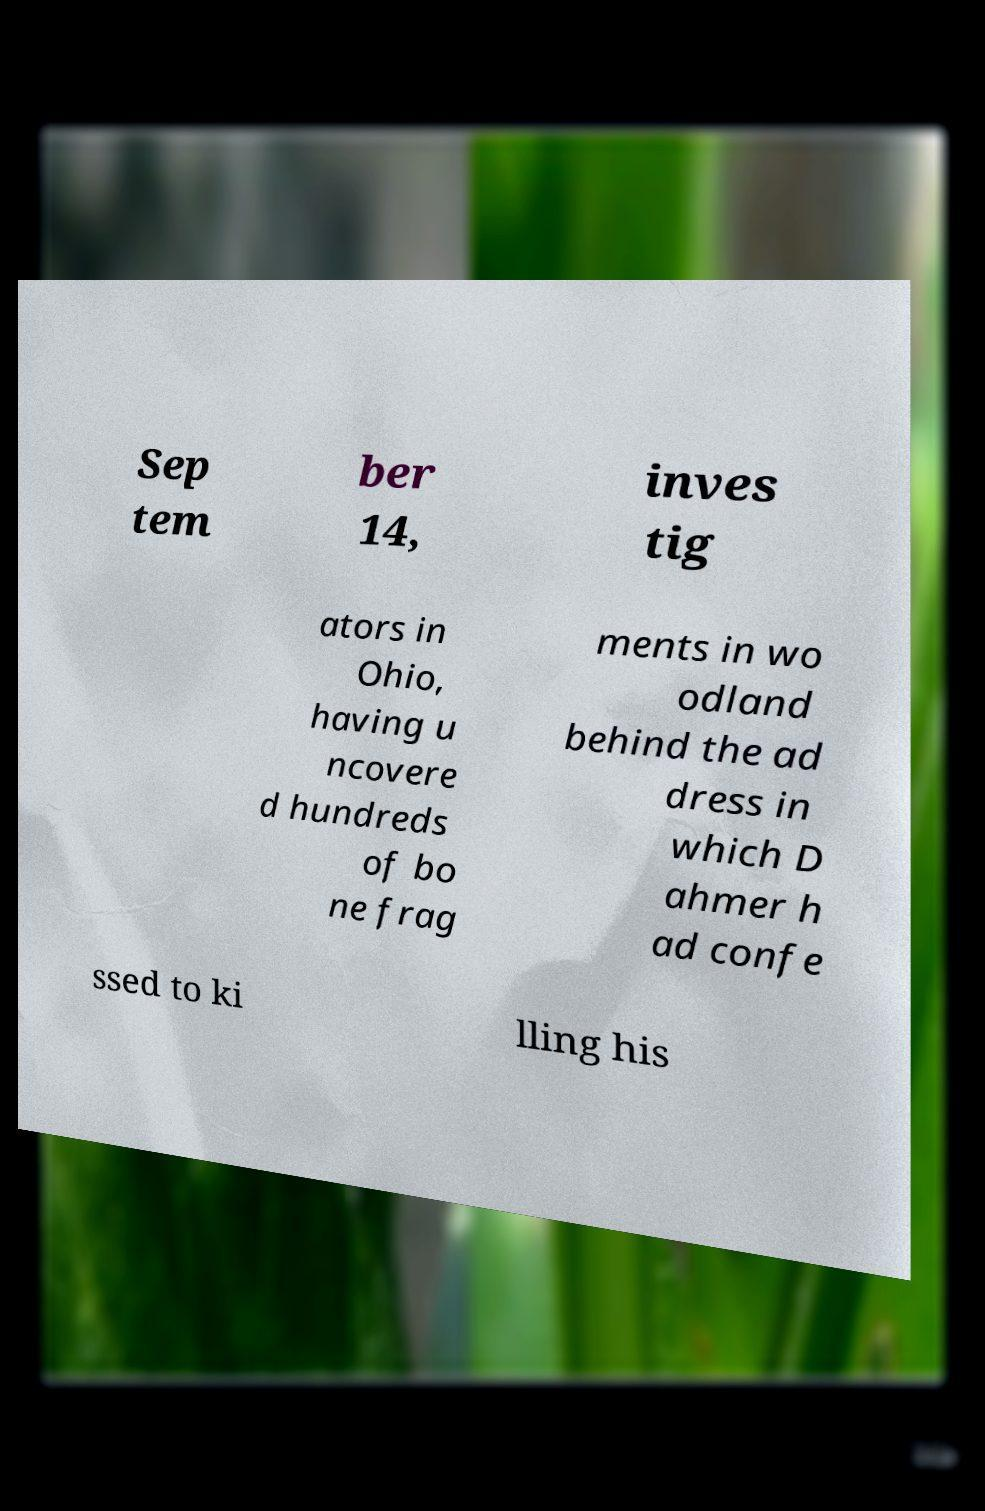Could you assist in decoding the text presented in this image and type it out clearly? Sep tem ber 14, inves tig ators in Ohio, having u ncovere d hundreds of bo ne frag ments in wo odland behind the ad dress in which D ahmer h ad confe ssed to ki lling his 